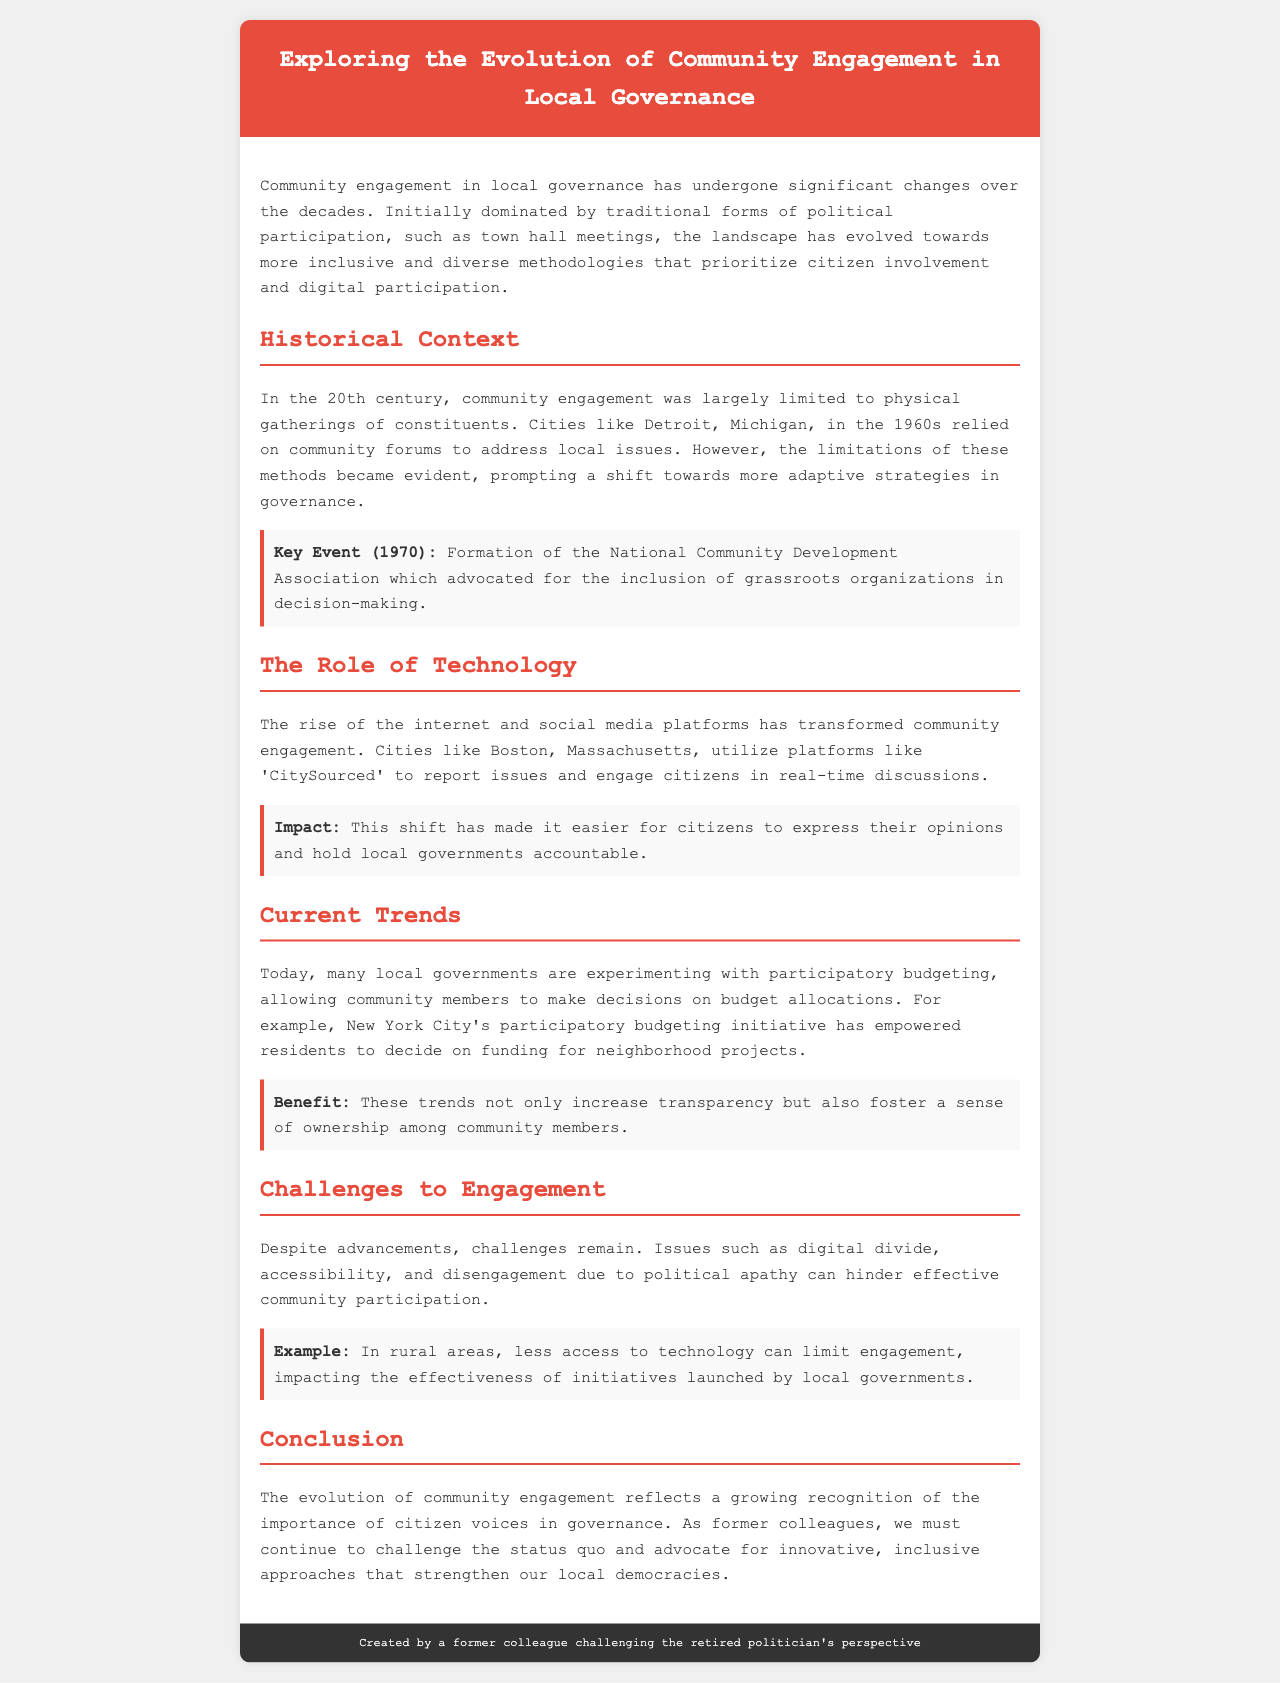What significant change occurred in the 20th century regarding community engagement? The document states that in the 20th century, community engagement was largely limited to physical gatherings of constituents.
Answer: Physical gatherings What year was the National Community Development Association formed? The document lists a key event in 1970 regarding the formation of the National Community Development Association.
Answer: 1970 Which city utilizes 'CitySourced' for community engagement? The document specifically mentions Boston, Massachusetts, using 'CitySourced' to engage citizens.
Answer: Boston What initiative allows community members to make decisions on budget allocations? The document mentions participatory budgeting as an initiative that allows community members to make decisions.
Answer: Participatory budgeting What is one challenge to community engagement mentioned in the brochure? The text outlines issues like digital divide as challenges to effective community participation.
Answer: Digital divide How did technology impact community engagement according to the document? The rise of the internet and social media transformed community engagement by making it easier for citizens to express opinions.
Answer: Easier citizen expression What is a key benefit of current trends in local governance mentioned? The text indicates that current trends increase transparency and foster a sense of ownership.
Answer: Increase transparency What does the conclusion emphasize regarding community engagement evolution? The conclusion reflects on the importance of citizen voices in governance and challenges the status quo for better approaches.
Answer: Importance of citizen voices 